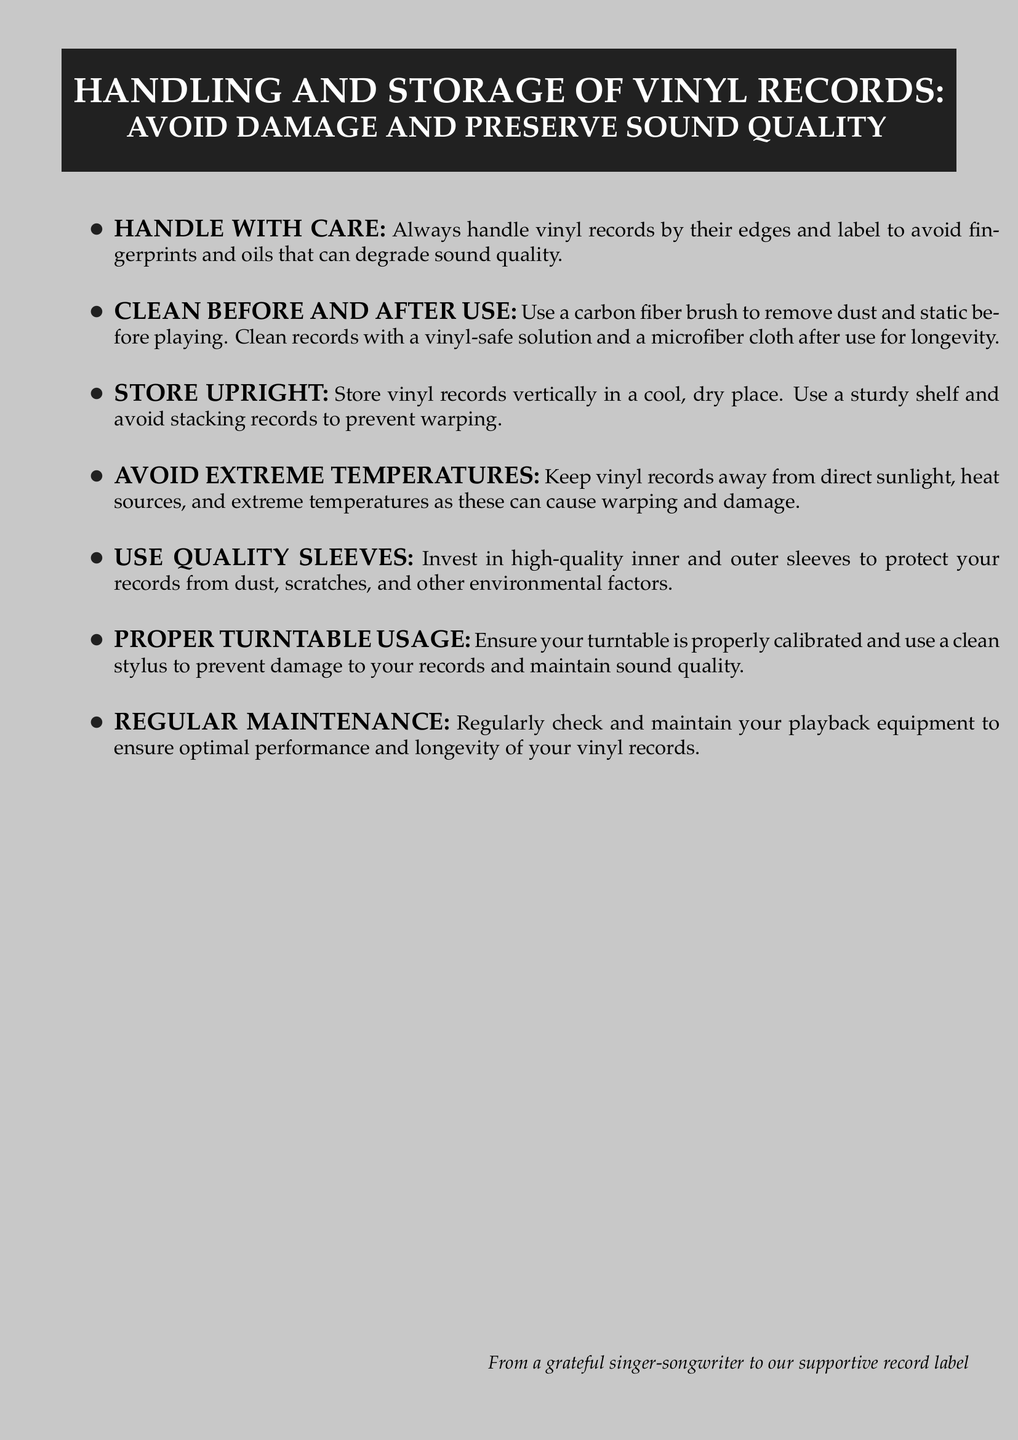what should you always handle vinyl records by? The document states to handle vinyl records by their edges and label.
Answer: their edges and label what type of brush should be used for cleaning? The document specifies to use a carbon fiber brush to remove dust and static before playing.
Answer: carbon fiber brush how should vinyl records be stored? The document advises to store vinyl records vertically in a cool, dry place.
Answer: vertically in a cool, dry place what can cause warping and damage to vinyl records? The document mentions that direct sunlight, heat sources, and extreme temperatures can cause warping and damage.
Answer: direct sunlight, heat sources, and extreme temperatures what should be used to protect records from dust and scratches? The document recommends investing in high-quality inner and outer sleeves for protection.
Answer: high-quality inner and outer sleeves what should be regularly checked for optimal performance? The document states that playback equipment should be regularly checked and maintained.
Answer: playback equipment what should be used to clean records after use? The document suggests using a vinyl-safe solution and a microfiber cloth to clean records after use.
Answer: a vinyl-safe solution and a microfiber cloth who is the document from? The document mentions that it is from a grateful singer-songwriter to their supportive record label.
Answer: a grateful singer-songwriter what is the consequence of not handling vinyl records properly? The document implies that not handling records properly can lead to fingerprints and oils degrading sound quality.
Answer: degrading sound quality 